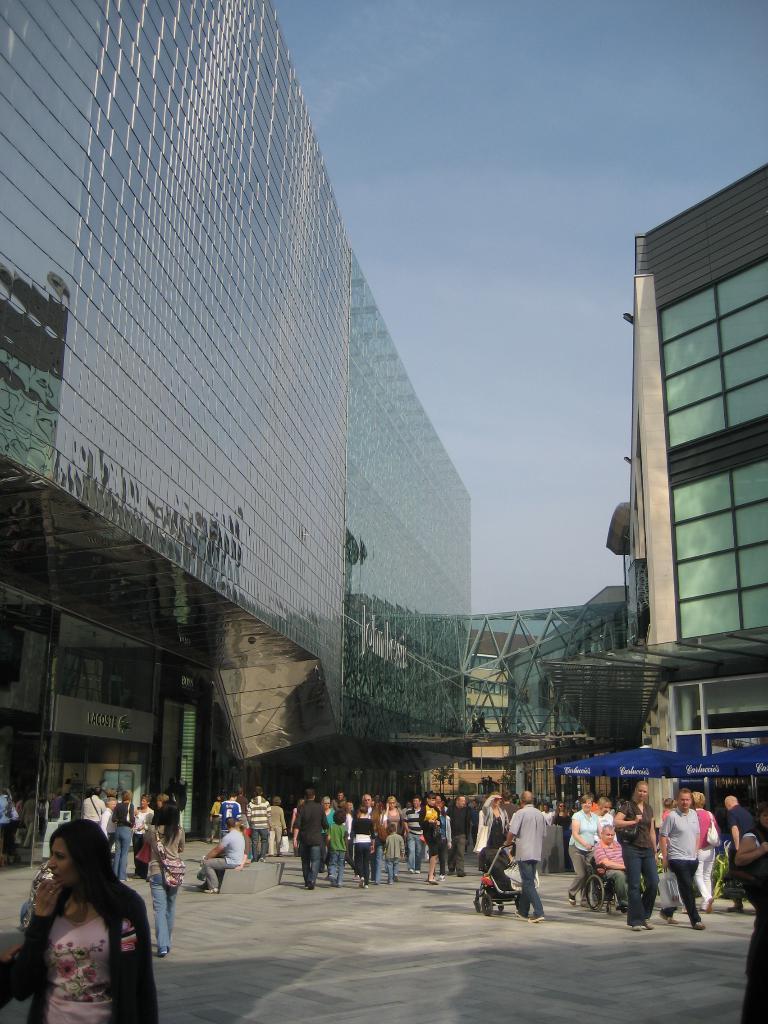How would you summarize this image in a sentence or two? In the image in the center we can see few people were standing and they were holding some objects. In the background we can see the sky,clouds,buildings,banners etc. 